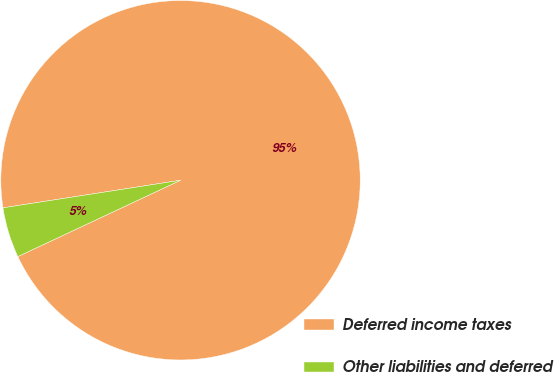<chart> <loc_0><loc_0><loc_500><loc_500><pie_chart><fcel>Deferred income taxes<fcel>Other liabilities and deferred<nl><fcel>95.47%<fcel>4.53%<nl></chart> 